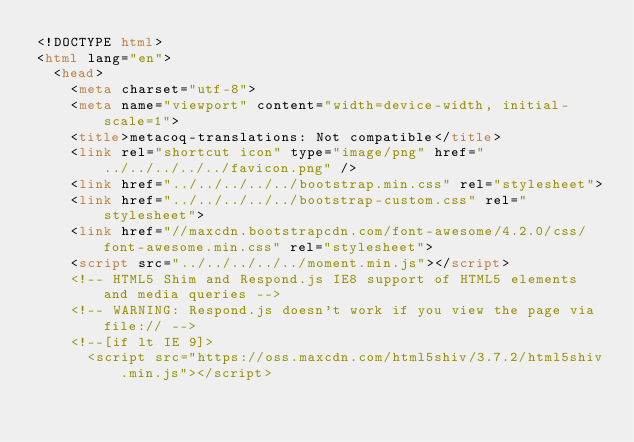Convert code to text. <code><loc_0><loc_0><loc_500><loc_500><_HTML_><!DOCTYPE html>
<html lang="en">
  <head>
    <meta charset="utf-8">
    <meta name="viewport" content="width=device-width, initial-scale=1">
    <title>metacoq-translations: Not compatible</title>
    <link rel="shortcut icon" type="image/png" href="../../../../../favicon.png" />
    <link href="../../../../../bootstrap.min.css" rel="stylesheet">
    <link href="../../../../../bootstrap-custom.css" rel="stylesheet">
    <link href="//maxcdn.bootstrapcdn.com/font-awesome/4.2.0/css/font-awesome.min.css" rel="stylesheet">
    <script src="../../../../../moment.min.js"></script>
    <!-- HTML5 Shim and Respond.js IE8 support of HTML5 elements and media queries -->
    <!-- WARNING: Respond.js doesn't work if you view the page via file:// -->
    <!--[if lt IE 9]>
      <script src="https://oss.maxcdn.com/html5shiv/3.7.2/html5shiv.min.js"></script></code> 